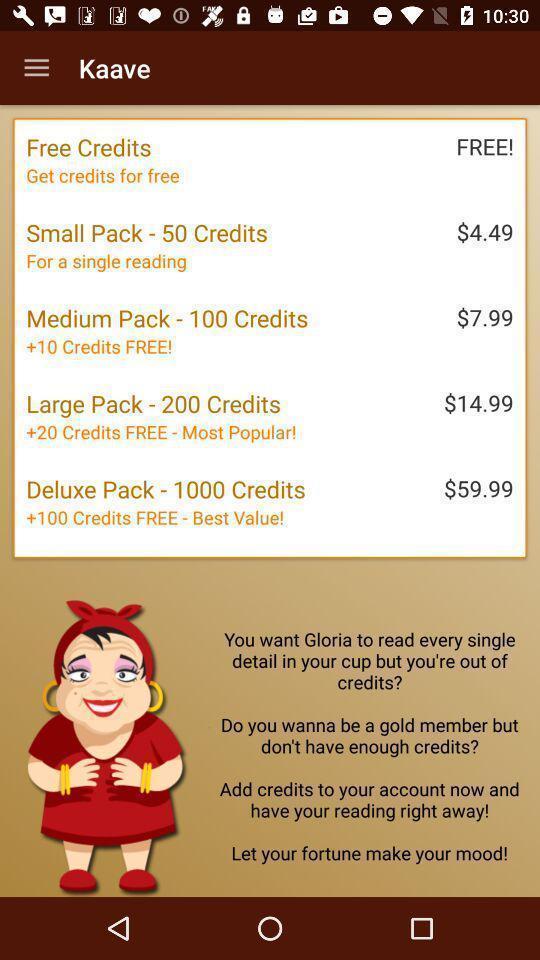Please provide a description for this image. Window displaying an fortune telling app. 